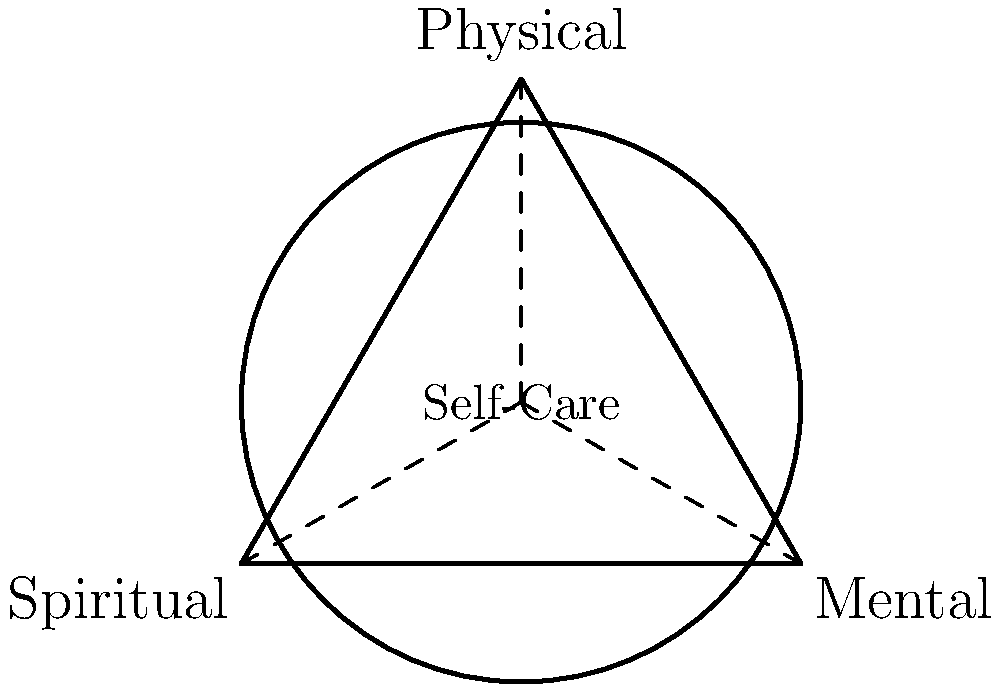In the diagram above, which represents the interconnectedness of spiritual, mental, and physical health, what geometric shape is formed by connecting the three aspects (spiritual, mental, and physical)? To determine the geometric shape formed by connecting the three aspects, let's analyze the diagram step-by-step:

1. Observe that there are three points labeled "Spiritual," "Mental," and "Physical" on the circumference of a circle.

2. These three points are connected by solid lines, forming a closed shape.

3. The shape has three vertices (one for each aspect of health) and three edges (the lines connecting them).

4. All three sides appear to be of equal length, as they are radii of the same circle.

5. The angles between each pair of sides also appear to be equal, as they are distributed evenly around the circle's center.

6. A closed shape with three equal sides and three equal angles is the definition of an equilateral triangle.

Therefore, the geometric shape formed by connecting the three aspects of health (spiritual, mental, and physical) is an equilateral triangle.
Answer: Equilateral triangle 